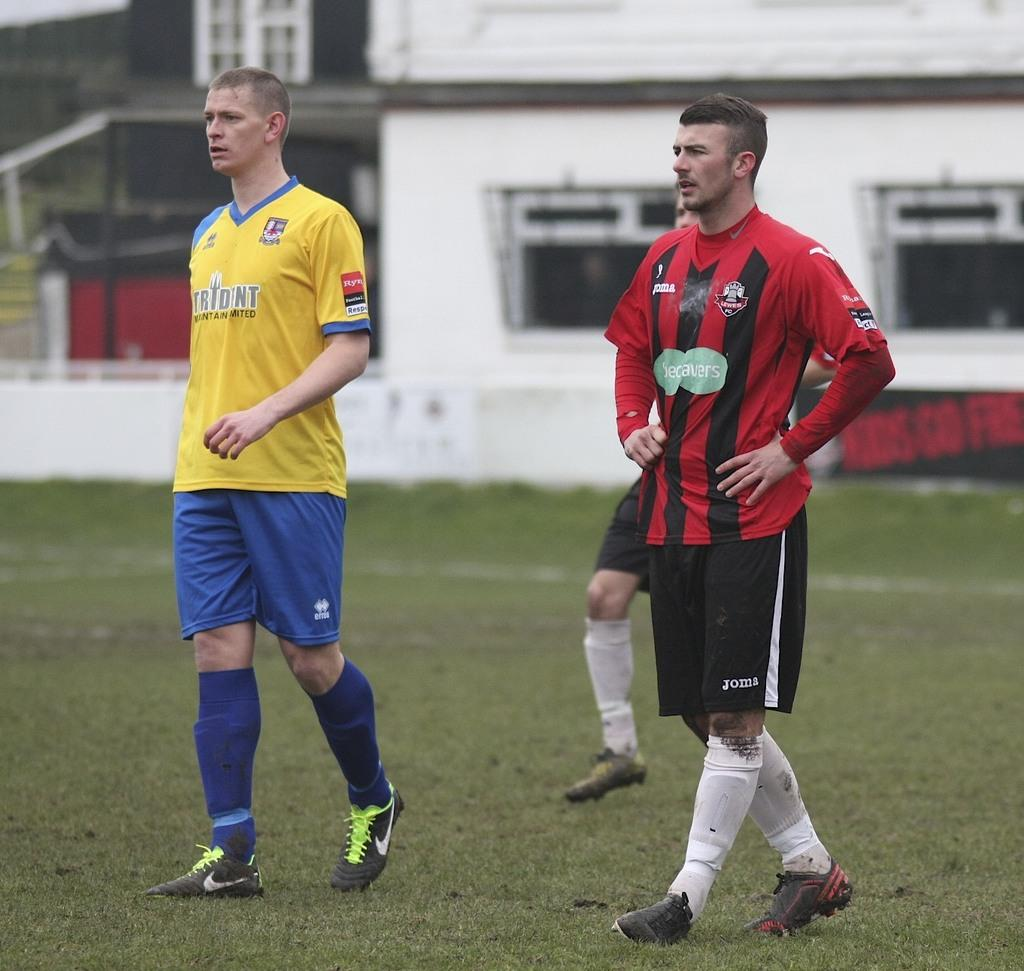<image>
Render a clear and concise summary of the photo. two soccer players look on a field and one wears black shorts with JOM on it 